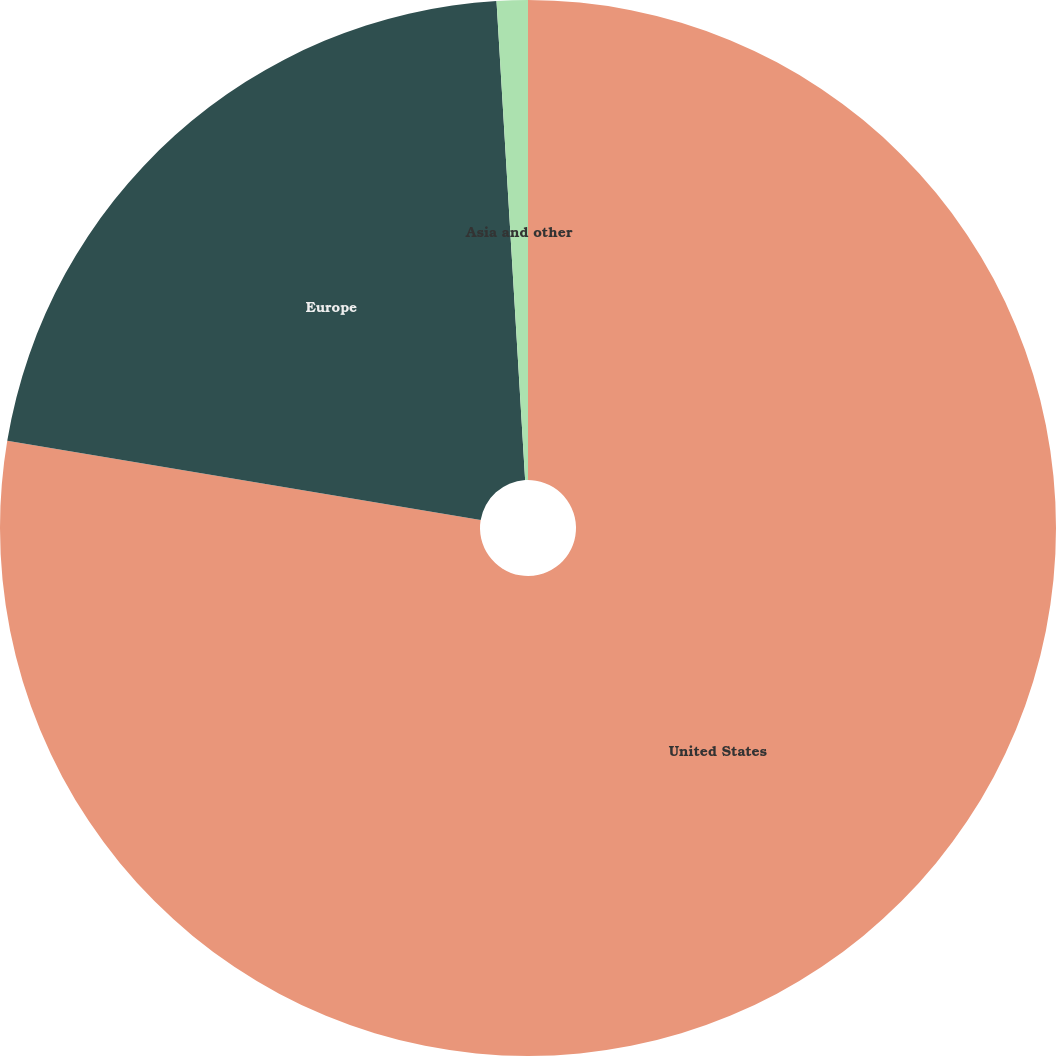<chart> <loc_0><loc_0><loc_500><loc_500><pie_chart><fcel>United States<fcel>Europe<fcel>Asia and other<nl><fcel>77.64%<fcel>21.41%<fcel>0.95%<nl></chart> 